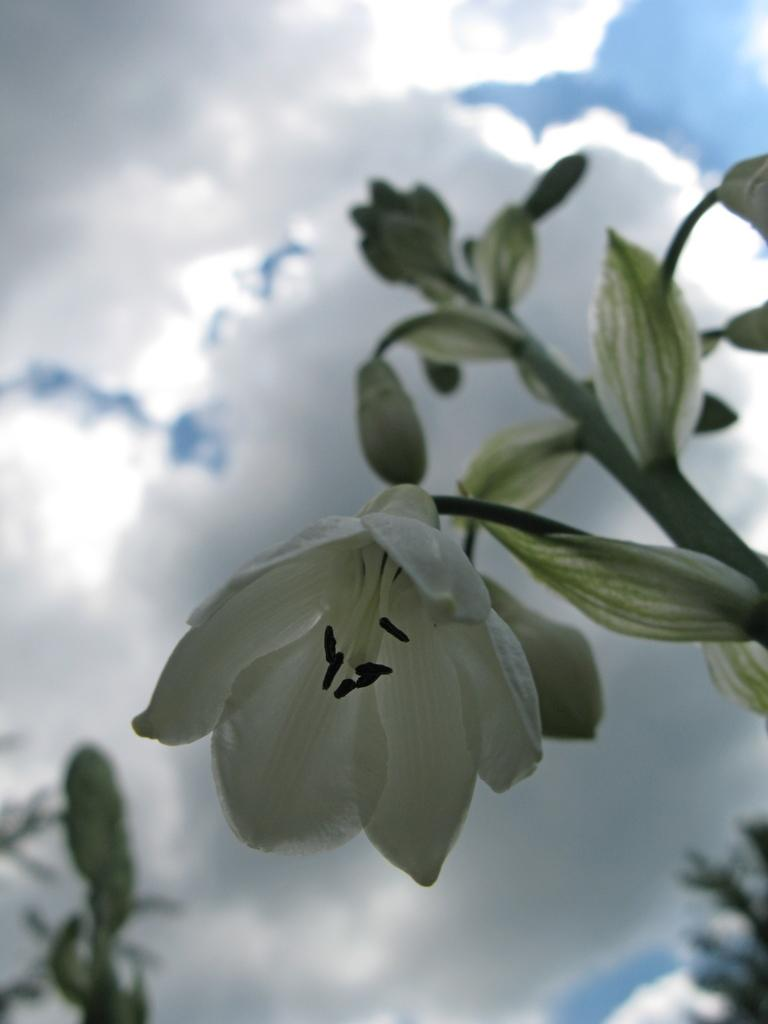What type of living organisms can be seen in the image? Plants can be seen in the image. Are there any specific features of the plants that are visible? Some of the plants have flowers. What can be seen in the background of the image? The sky is visible in the image. What is the condition of the sky in the image? Clouds are present in the sky. Can you tell me how many feet are visible in the image? There are no feet present in the image; it features plants and a sky with clouds. What type of vest is being worn by the plant in the image? There is no plant wearing a vest in the image; plants do not wear clothing. 